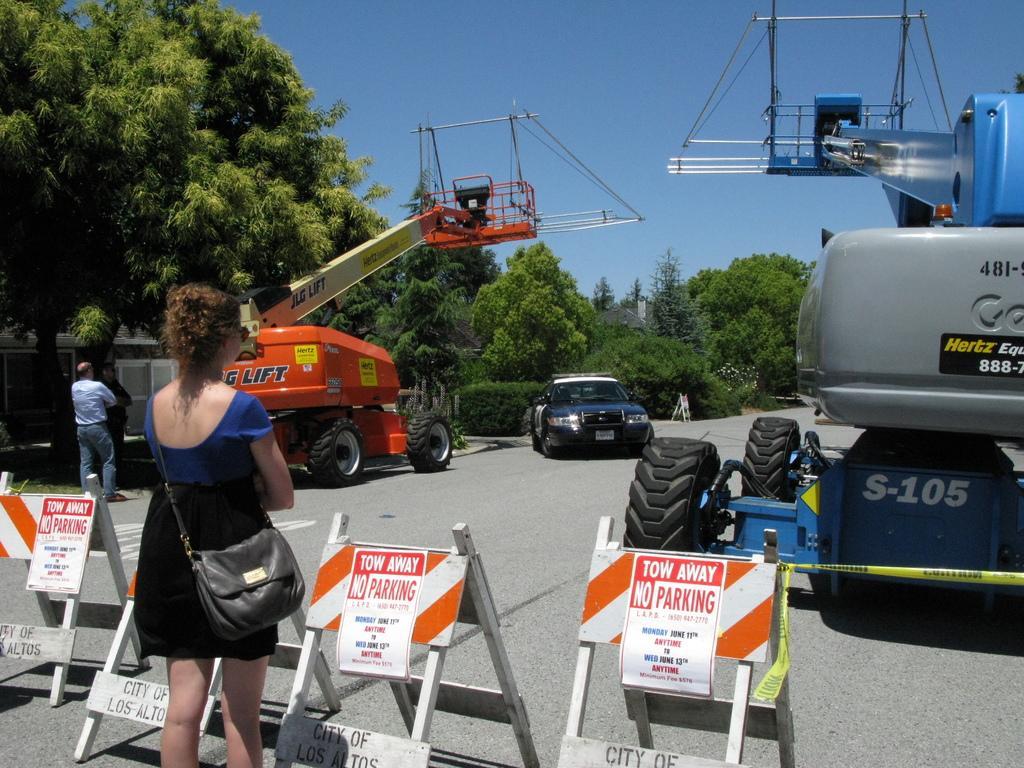Please provide a concise description of this image. This picture shows two cranes and a car and a woman standing and few trees around 